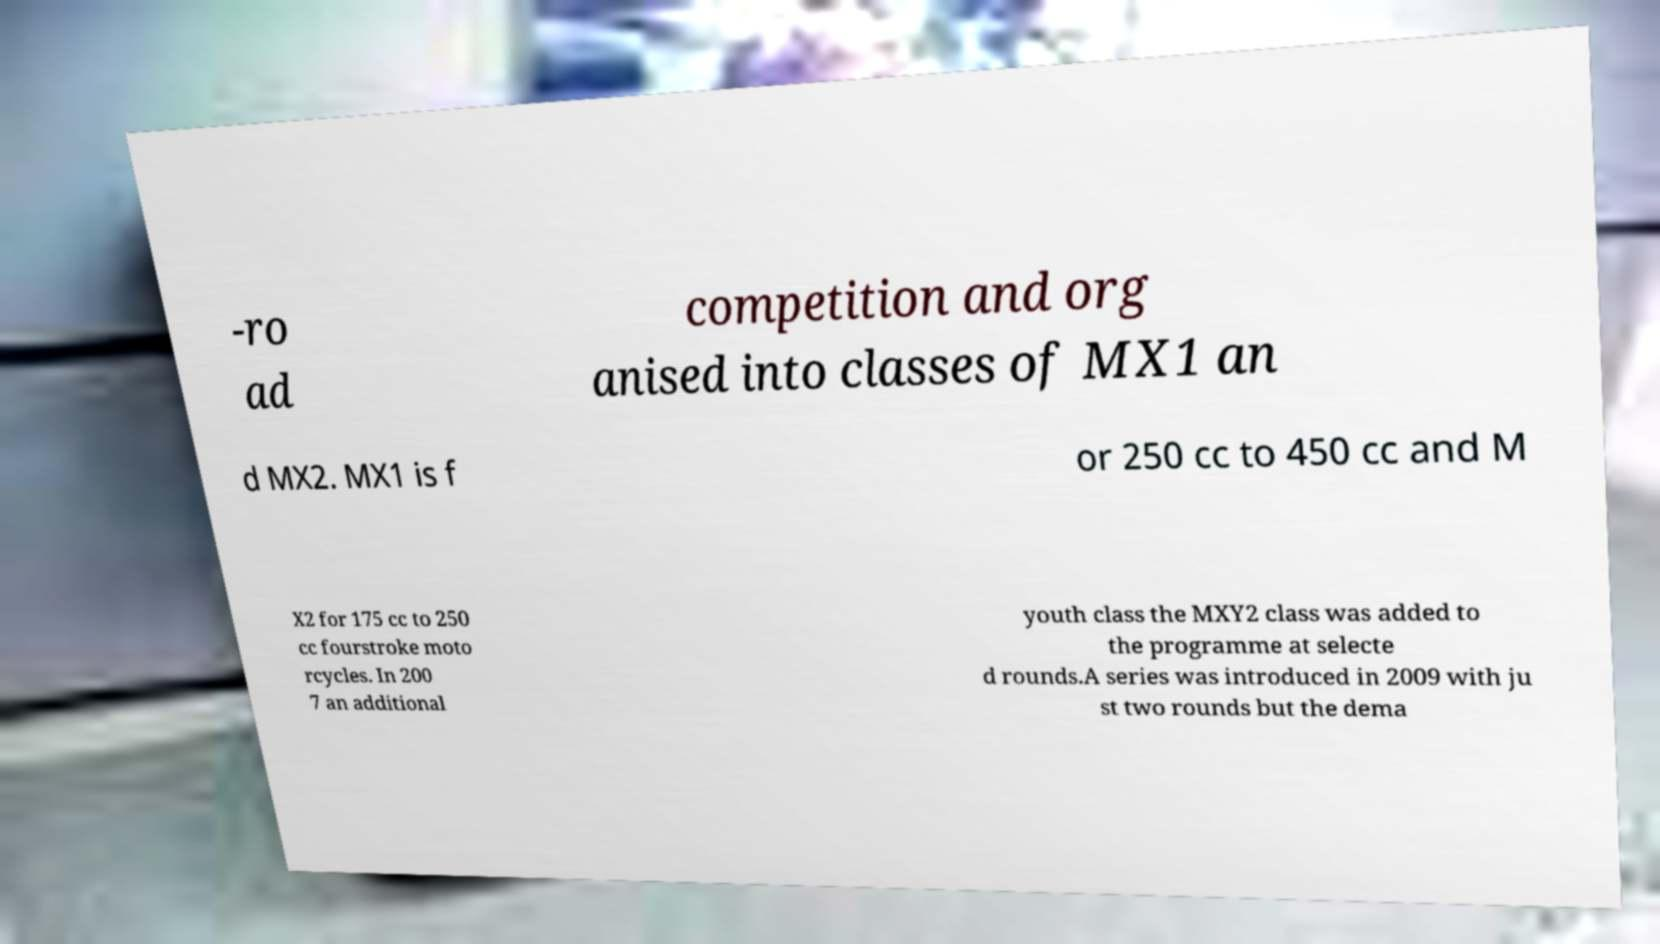Can you read and provide the text displayed in the image?This photo seems to have some interesting text. Can you extract and type it out for me? -ro ad competition and org anised into classes of MX1 an d MX2. MX1 is f or 250 cc to 450 cc and M X2 for 175 cc to 250 cc fourstroke moto rcycles. In 200 7 an additional youth class the MXY2 class was added to the programme at selecte d rounds.A series was introduced in 2009 with ju st two rounds but the dema 